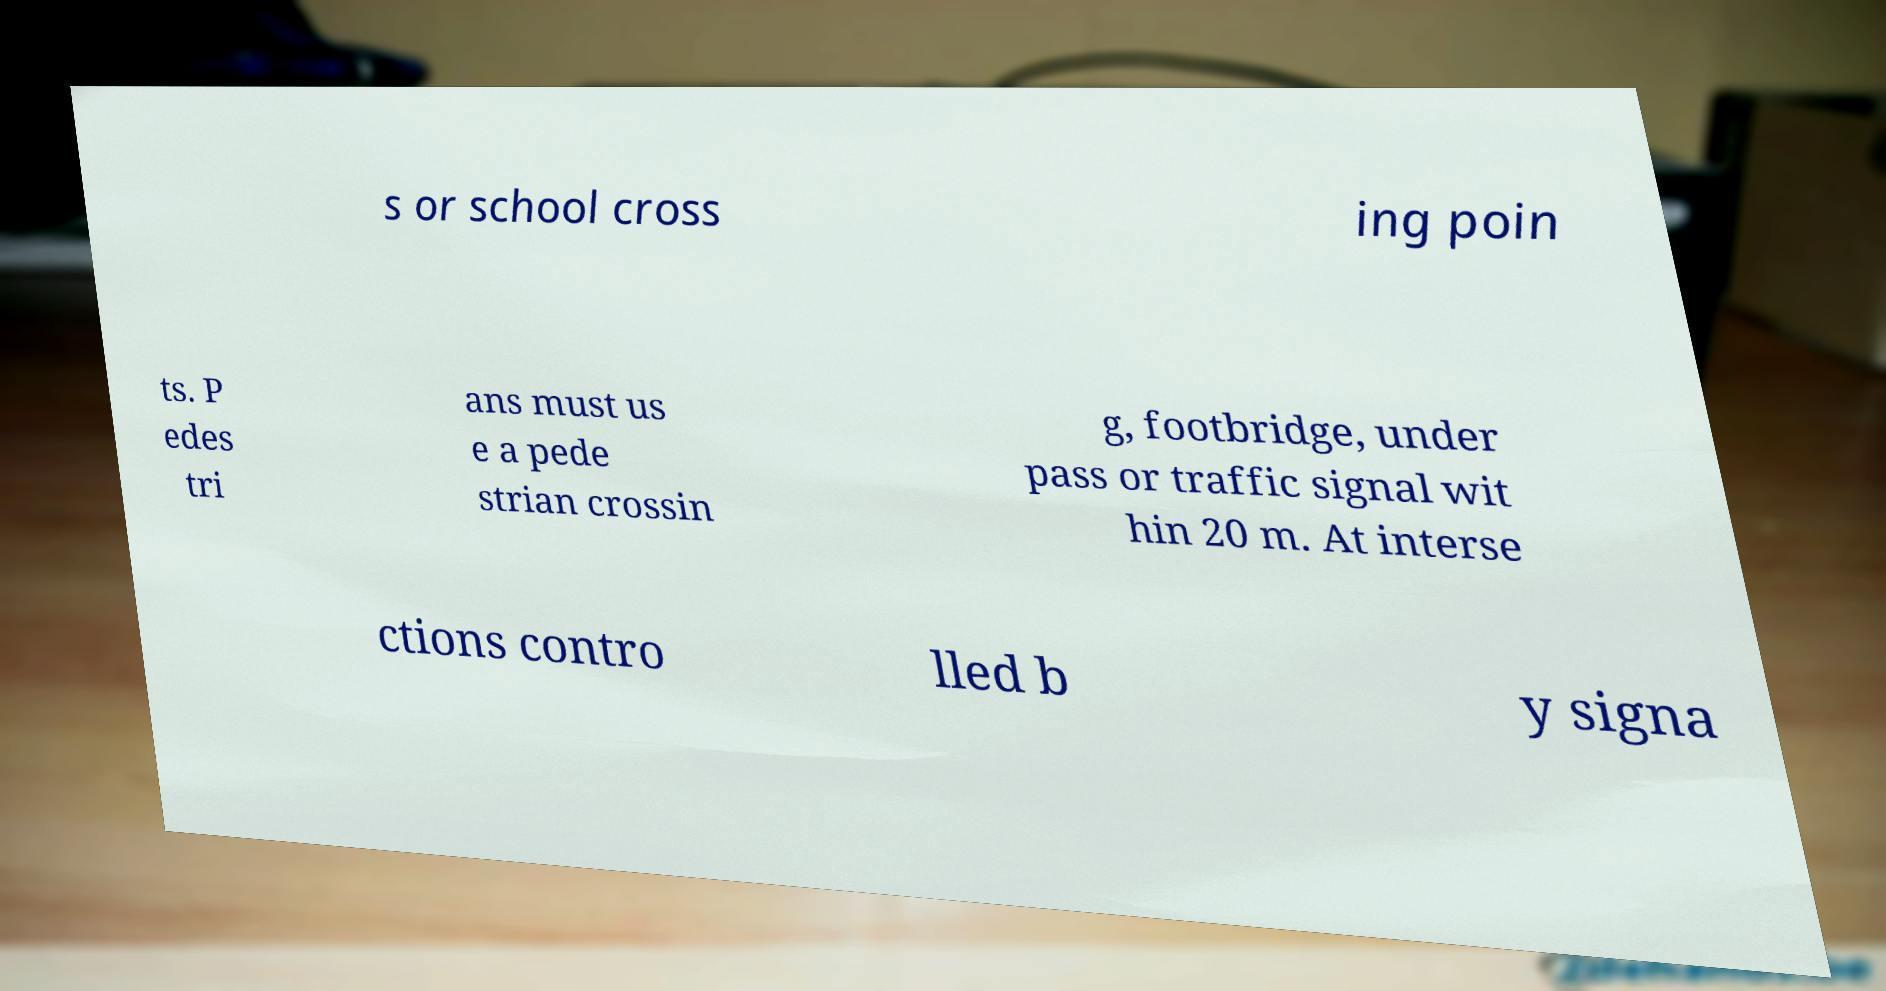I need the written content from this picture converted into text. Can you do that? s or school cross ing poin ts. P edes tri ans must us e a pede strian crossin g, footbridge, under pass or traffic signal wit hin 20 m. At interse ctions contro lled b y signa 